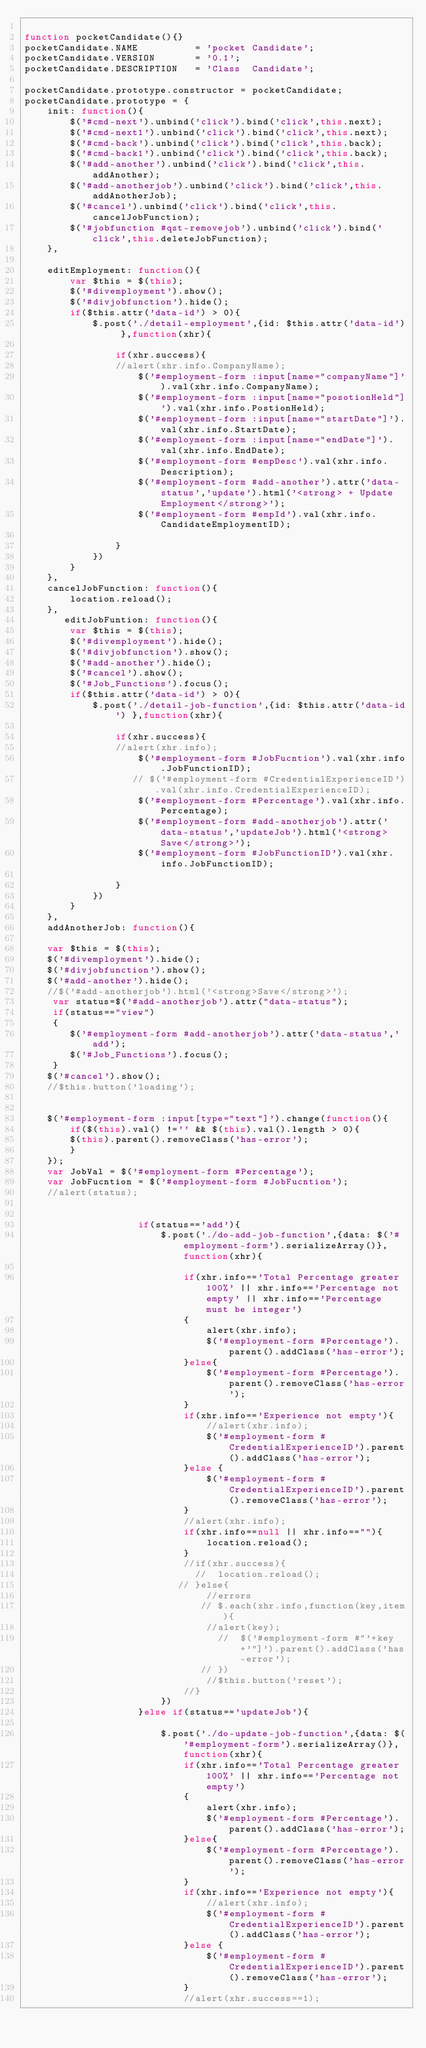<code> <loc_0><loc_0><loc_500><loc_500><_JavaScript_>
function pocketCandidate(){}
pocketCandidate.NAME          = 'pocket Candidate';
pocketCandidate.VERSION       = '0.1';
pocketCandidate.DESCRIPTION   = 'Class  Candidate';

pocketCandidate.prototype.constructor = pocketCandidate;
pocketCandidate.prototype = {
    init: function(){
        $('#cmd-next').unbind('click').bind('click',this.next);
        $('#cmd-next1').unbind('click').bind('click',this.next);
        $('#cmd-back').unbind('click').bind('click',this.back);
        $('#cmd-back1').unbind('click').bind('click',this.back);
        $('#add-another').unbind('click').bind('click',this.addAnother);
		$('#add-anotherjob').unbind('click').bind('click',this.addAnotherJob);
		$('#cancel').unbind('click').bind('click',this.cancelJobFunction);
		$('#jobfunction #qst-removejob').unbind('click').bind('click',this.deleteJobFunction);
    },
	
    editEmployment: function(){
        var $this = $(this);
		$('#divemployment').show();
        $('#divjobfunction').hide();
        if($this.attr('data-id') > 0){
            $.post('./detail-employment',{id: $this.attr('data-id') },function(xhr){

                if(xhr.success){
				//alert(xhr.info.CompanyName);
                    $('#employment-form :input[name="companyName"]').val(xhr.info.CompanyName);
                    $('#employment-form :input[name="posotionHeld"]').val(xhr.info.PostionHeld);
                    $('#employment-form :input[name="startDate"]').val(xhr.info.StartDate);
                    $('#employment-form :input[name="endDate"]').val(xhr.info.EndDate);
                    $('#employment-form #empDesc').val(xhr.info.Description);
                    $('#employment-form #add-another').attr('data-status','update').html('<strong> + Update Employment</strong>');
                    $('#employment-form #empId').val(xhr.info.CandidateEmploymentID);

                }
            })
        }
    },
	cancelJobFunction: function(){
		location.reload();
	},
	   editJobFuntion: function(){
        var $this = $(this);
		$('#divemployment').hide();
        $('#divjobfunction').show();
		$('#add-another').hide();
		$('#cancel').show();
		$('#Job_Functions').focus();
        if($this.attr('data-id') > 0){
            $.post('./detail-job-function',{id: $this.attr('data-id') },function(xhr){

                if(xhr.success){
				//alert(xhr.info);
                    $('#employment-form #JobFucntion').val(xhr.info.JobFunctionID);
                   // $('#employment-form #CredentialExperienceID').val(xhr.info.CredentialExperienceID);
					$('#employment-form #Percentage').val(xhr.info.Percentage);
                    $('#employment-form #add-anotherjob').attr('data-status','updateJob').html('<strong>Save</strong>');
                    $('#employment-form #JobFunctionID').val(xhr.info.JobFunctionID);

                }
            })
        }
    },
	addAnotherJob: function(){
		
	var $this = $(this);
	$('#divemployment').hide();
	$('#divjobfunction').show();
	$('#add-another').hide();
	//$('#add-anotherjob').html('<strong>Save</strong>');
	 var status=$('#add-anotherjob').attr("data-status");
	 if(status=="view")
	 {
		$('#employment-form #add-anotherjob').attr('data-status','add');
		$('#Job_Functions').focus();
	 }
	$('#cancel').show();
	//$this.button('loading');
	

	$('#employment-form :input[type="text"]').change(function(){
		if($(this).val() !='' && $(this).val().length > 0){
		$(this).parent().removeClass('has-error');
		}
	});
	var JobVal = $('#employment-form #Percentage');
	var JobFucntion = $('#employment-form #JobFucntion');
	//alert(status);


					if(status=='add'){
						$.post('./do-add-job-function',{data: $('#employment-form').serializeArray()},function(xhr){
							
							if(xhr.info=='Total Percentage greater 100%' || xhr.info=='Percentage not empty' || xhr.info=='Percentage must be integer')
							{
								alert(xhr.info);
								$('#employment-form #Percentage').parent().addClass('has-error');
							}else{
								$('#employment-form #Percentage').parent().removeClass('has-error');
							}
							if(xhr.info=='Experience not empty'){
								//alert(xhr.info);
								$('#employment-form #CredentialExperienceID').parent().addClass('has-error');
							}else {
								$('#employment-form #CredentialExperienceID').parent().removeClass('has-error');
							}
							//alert(xhr.info);
							if(xhr.info==null || xhr.info==""){
								location.reload();
							}
							//if(xhr.success){
							  //  location.reload();
						   // }else{
								//errors
							   // $.each(xhr.info,function(key,item){
								//alert(key);
								  //  $('#employment-form #"'+key+'"]').parent().addClass('has-error');
							   // })
								//$this.button('reset');
							//}
						})
					}else if(status=='updateJob'){
						
						$.post('./do-update-job-function',{data: $('#employment-form').serializeArray()},function(xhr){
							if(xhr.info=='Total Percentage greater 100%' || xhr.info=='Percentage not empty')
							{
								alert(xhr.info);
								$('#employment-form #Percentage').parent().addClass('has-error');
							}else{
								$('#employment-form #Percentage').parent().removeClass('has-error');
							}
							if(xhr.info=='Experience not empty'){
								//alert(xhr.info);
								$('#employment-form #CredentialExperienceID').parent().addClass('has-error');
							}else {
								$('#employment-form #CredentialExperienceID').parent().removeClass('has-error');
							}
							//alert(xhr.success==1);</code> 